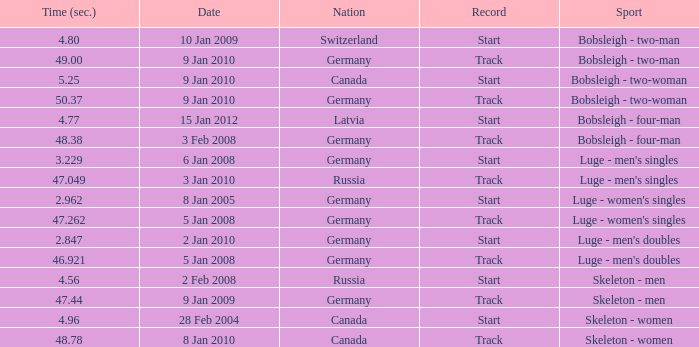In which country was a time of 48.38 achieved? Germany. 